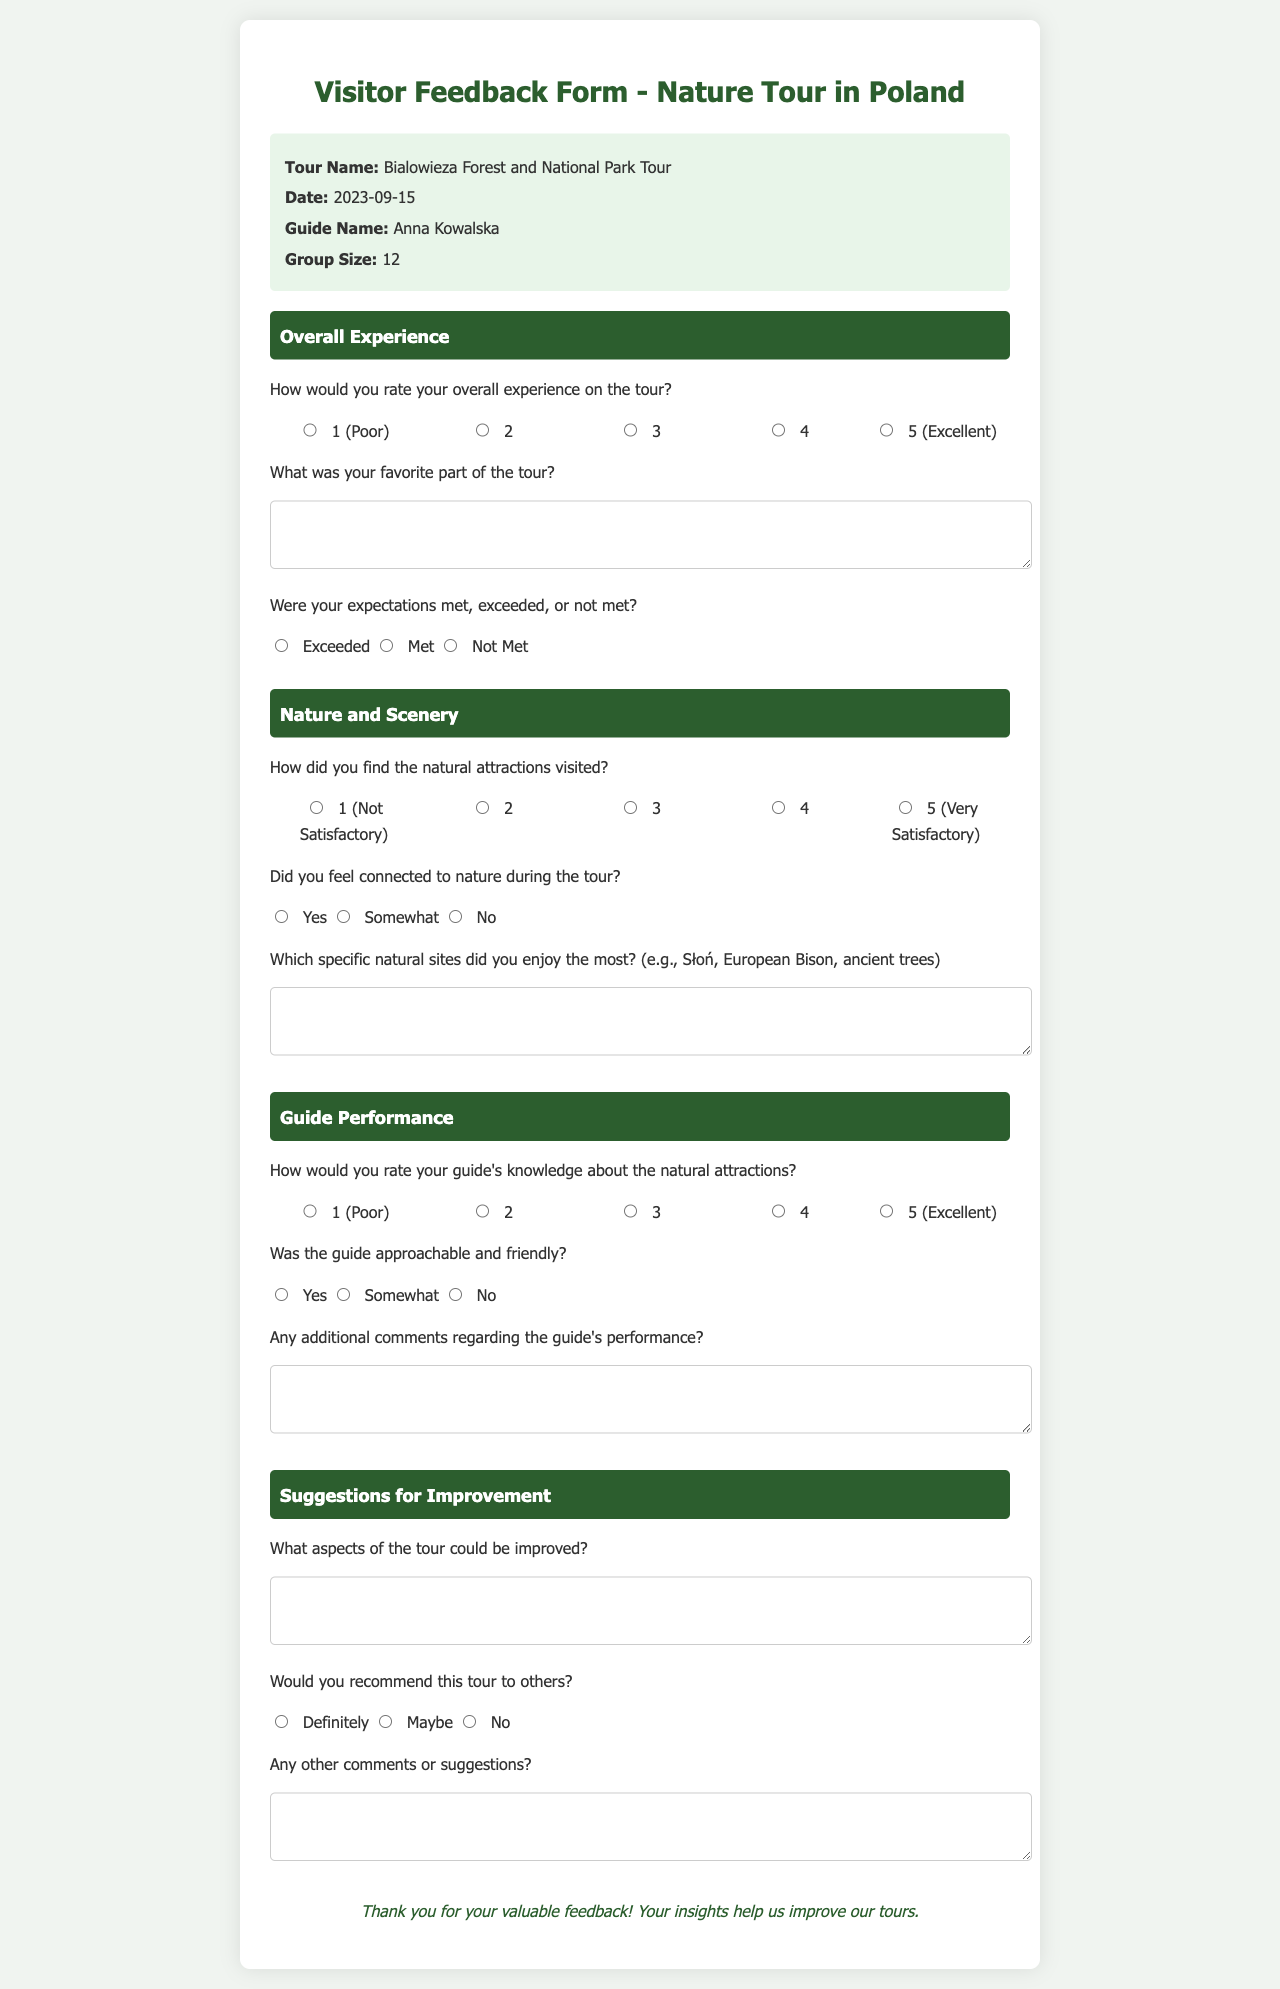What is the name of the tour? The name of the tour is provided in the tour details section of the document.
Answer: Bialowieza Forest and National Park Tour Who is the guide for the tour? The document specifies the guide's name in the tour details section.
Answer: Anna Kowalska What date was the tour held? The date of the tour is mentioned in the tour details section of the document.
Answer: 2023-09-15 How many people were in the group? The document indicates the group size in the tour details section.
Answer: 12 What rating scale is used for the overall experience? The document uses a scale from 1 to 5 to assess overall experience in the first section.
Answer: 1 to 5 How did the document ask if participants felt connected to nature? The document includes a question regarding connection to nature, offering three response options.
Answer: Yes, Somewhat, No What are participants asked to provide feedback on in the suggestions section? The document includes a specific question asking participants what aspects could be improved.
Answer: Aspects of the tour Would the participants recommend the tour to others? The document questions participants on their likelihood to recommend the tour.
Answer: Definitely, Maybe, No How should participants provide their favorite part of the tour? The document includes a textarea for participants to describe their favorite part of the tour.
Answer: Textarea response 